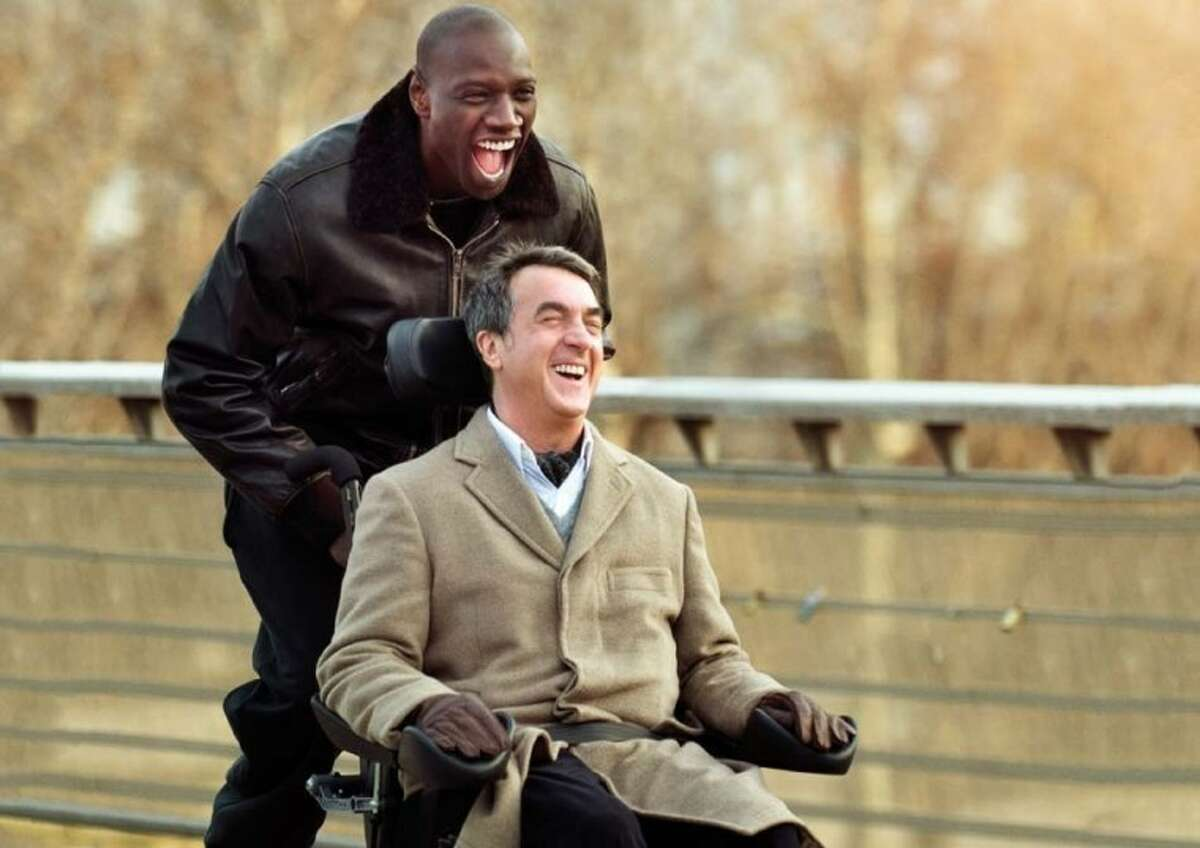Can you describe the main features of this image for me? This image captures a delightful moment from 'The Intouchables', featuring actors François Cluzet and Omar Sy exuberantly sharing a laugh. François is in a wheelchair, dressed warmly in a beige coat, vividly laughing. Omar, standing behind, wears a stylish black leather jacket, his laughter equally infectious. They are on a picturesque bridge, the wintry trees in the background adding a serene, almost ethereal quality to the scene. This image is emblematic of the film’s exploration of friendship and joy transcending societal boundaries. 